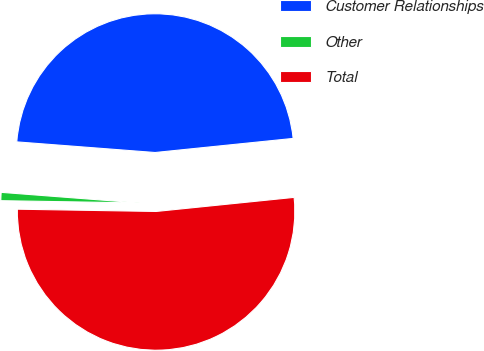<chart> <loc_0><loc_0><loc_500><loc_500><pie_chart><fcel>Customer Relationships<fcel>Other<fcel>Total<nl><fcel>47.16%<fcel>0.96%<fcel>51.88%<nl></chart> 